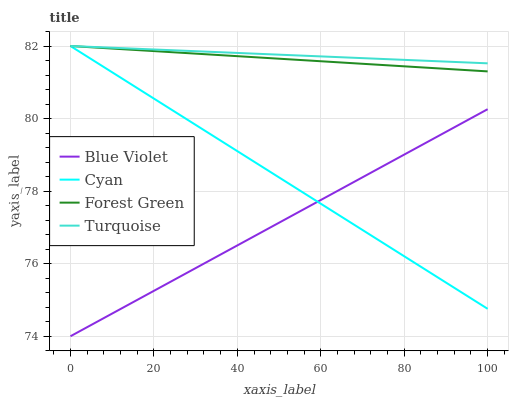Does Blue Violet have the minimum area under the curve?
Answer yes or no. Yes. Does Turquoise have the maximum area under the curve?
Answer yes or no. Yes. Does Forest Green have the minimum area under the curve?
Answer yes or no. No. Does Forest Green have the maximum area under the curve?
Answer yes or no. No. Is Blue Violet the smoothest?
Answer yes or no. Yes. Is Cyan the roughest?
Answer yes or no. Yes. Is Forest Green the smoothest?
Answer yes or no. No. Is Forest Green the roughest?
Answer yes or no. No. Does Forest Green have the lowest value?
Answer yes or no. No. Does Turquoise have the highest value?
Answer yes or no. Yes. Does Blue Violet have the highest value?
Answer yes or no. No. Is Blue Violet less than Turquoise?
Answer yes or no. Yes. Is Turquoise greater than Blue Violet?
Answer yes or no. Yes. Does Forest Green intersect Cyan?
Answer yes or no. Yes. Is Forest Green less than Cyan?
Answer yes or no. No. Is Forest Green greater than Cyan?
Answer yes or no. No. Does Blue Violet intersect Turquoise?
Answer yes or no. No. 